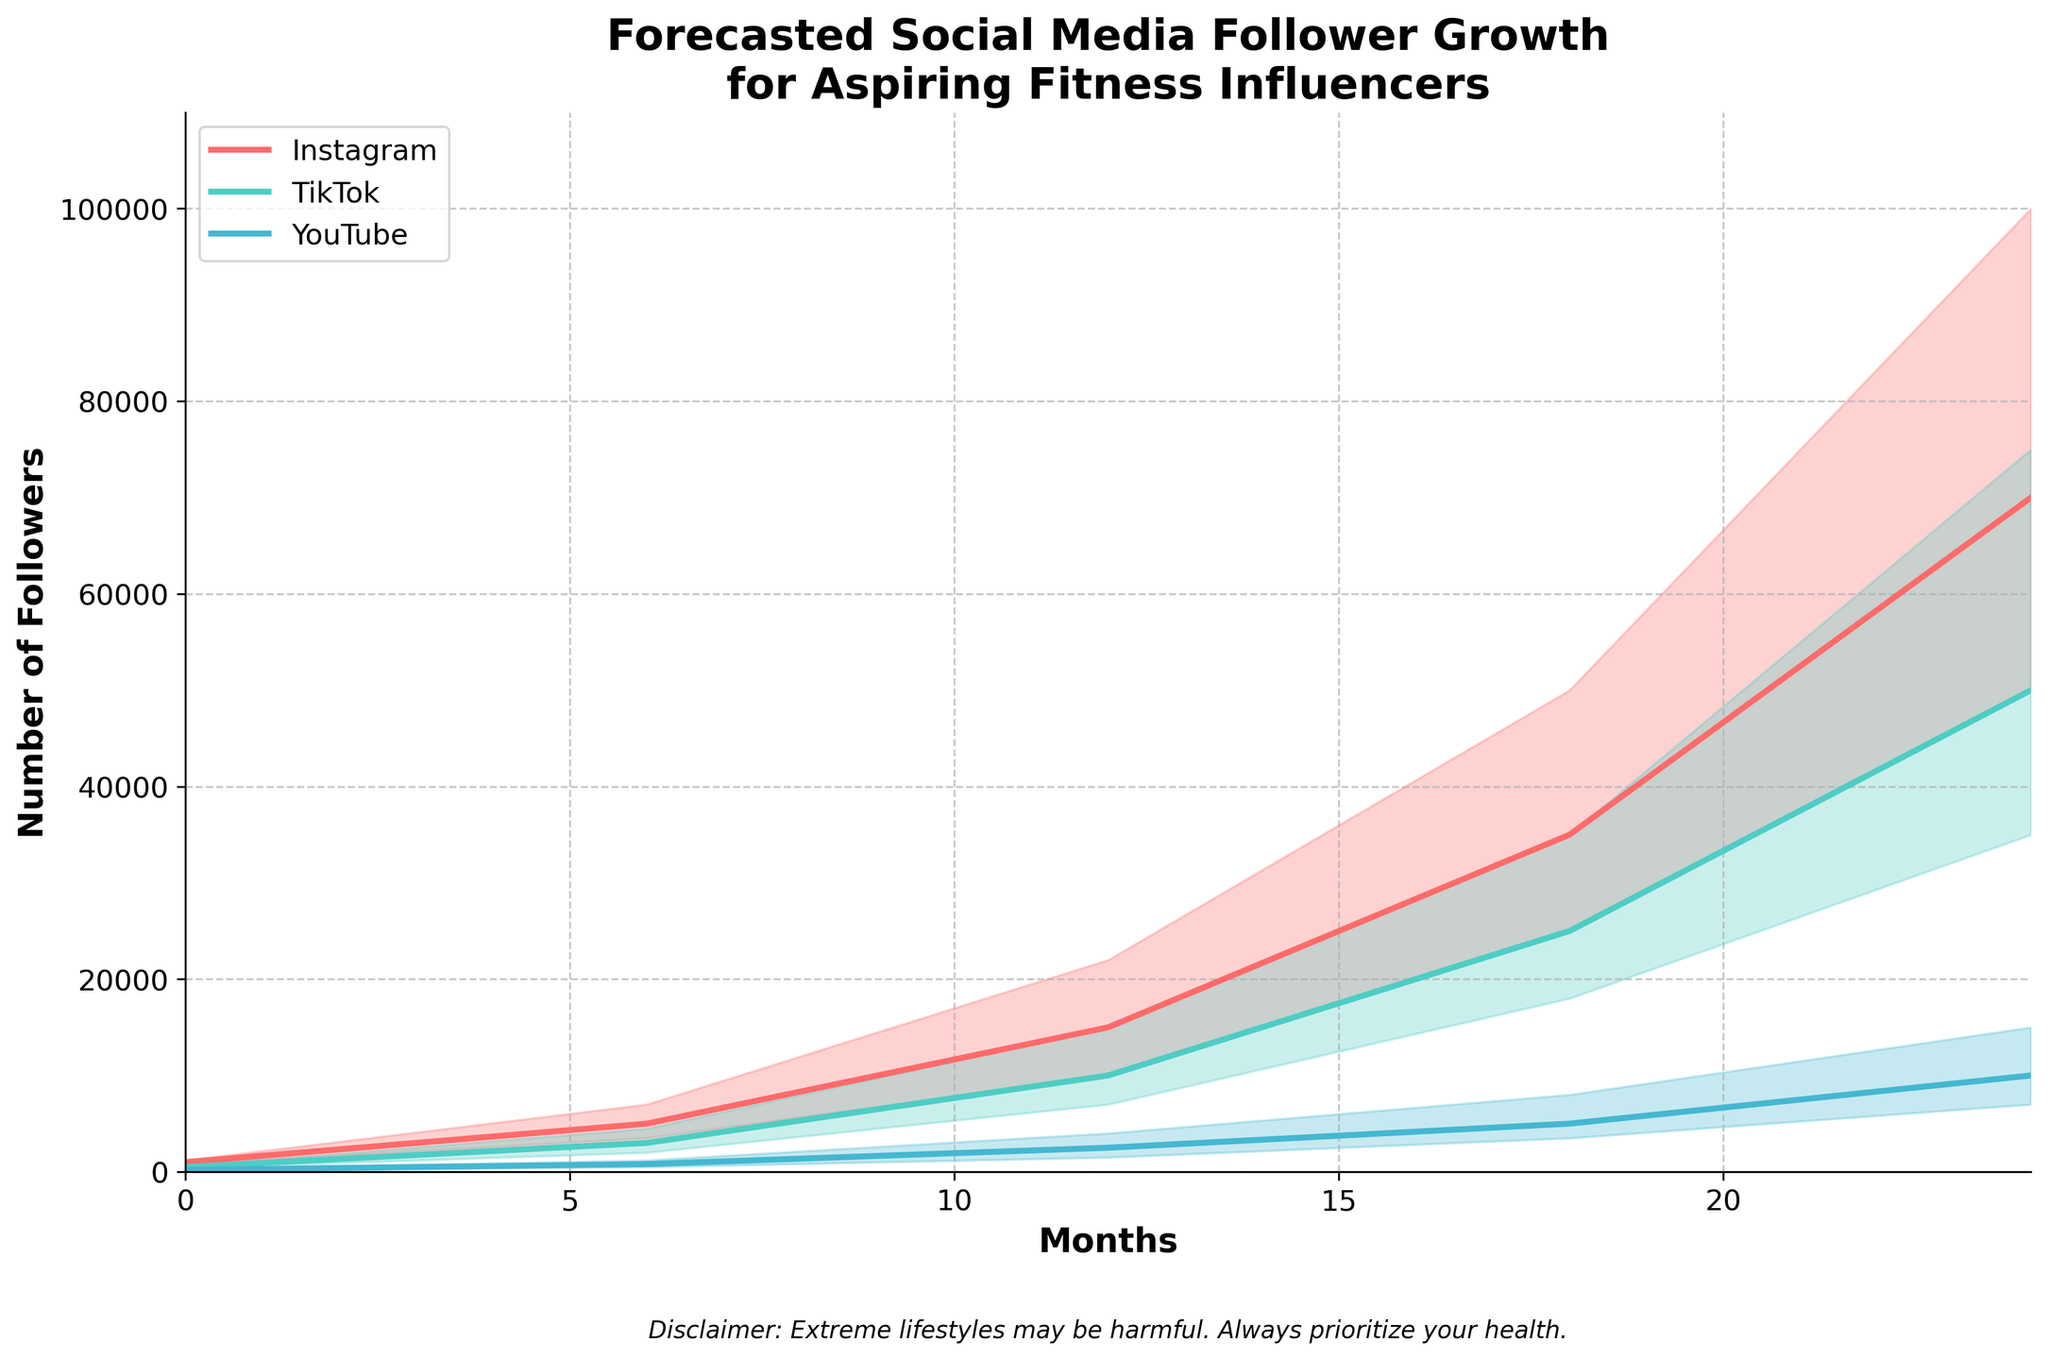What is the title of the chart? The title is displayed at the top of the chart, which provides a summary of what the chart represents. The title is "Forecasted Social Media Follower Growth for Aspiring Fitness Influencers."
Answer: Forecasted Social Media Follower Growth for Aspiring Fitness Influencers What is the y-axis label? The y-axis label, located vertically along the left side of the chart, details what the y-axis represents. The label is "Number of Followers."
Answer: Number of Followers How many platforms are being compared in the chart? By examining the legend and the plotted lines, you can identify the number of platforms being compared. There are three platforms: Instagram, TikTok, and YouTube.
Answer: Three At which month do Instagram followers reach a median of 15,000? Identify the point where the Instagram median line intersects with the 15,000 mark on the y-axis. This intersection happens at month 12.
Answer: 12 Which platform has the highest number of followers at month 24 according to the median line? Trace the median lines of each platform to month 24 and compare their values. Instagram's median is at 70,000, TikTok's median is at 50,000, and YouTube's median is at 10,000. Therefore, Instagram has the highest number of followers at month 24.
Answer: Instagram What is the range of TikTok followers at month 18? At month 18, locate the upper and lower bounds for TikTok. The lower bound is 18,000 and the upper bound is 35,000. The range is calculated as 35,000 - 18,000 = 17,000.
Answer: 17,000 Compare the median number of YouTube followers at month 6 with TikTok followers at the same month. Which is higher? Locate month 6 along the x-axis and compare the medians for YouTube and TikTok. YouTube’s median is 800, while TikTok’s median is 3,000. TikTok's median is higher.
Answer: TikTok How does the growth trend for Instagram compare to YouTube over the 24 months? Observe the slopes of the median lines for Instagram and YouTube over the span of 24 months. Instagram shows a rapidly increasing trend, rising from 1,000 to 70,000, while YouTube shows a much slower increase, rising from 200 to 10,000.
Answer: Instagram has a steeper growth trend What are the upper and lower bounds of Instagram followers at month 24? At month 24, locate the filled area for Instagram to determine the bounds. The lower bound is 50,000, and the upper bound is 100,000.
Answer: 50,000 and 100,000 What is the difference between the median number of followers for TikTok and YouTube at month 12? Identify the median values for both platforms at month 12: TikTok has 10,000 followers, and YouTube has 2,500 followers. The difference is calculated as 10,000 - 2,500 = 7,500.
Answer: 7,500 